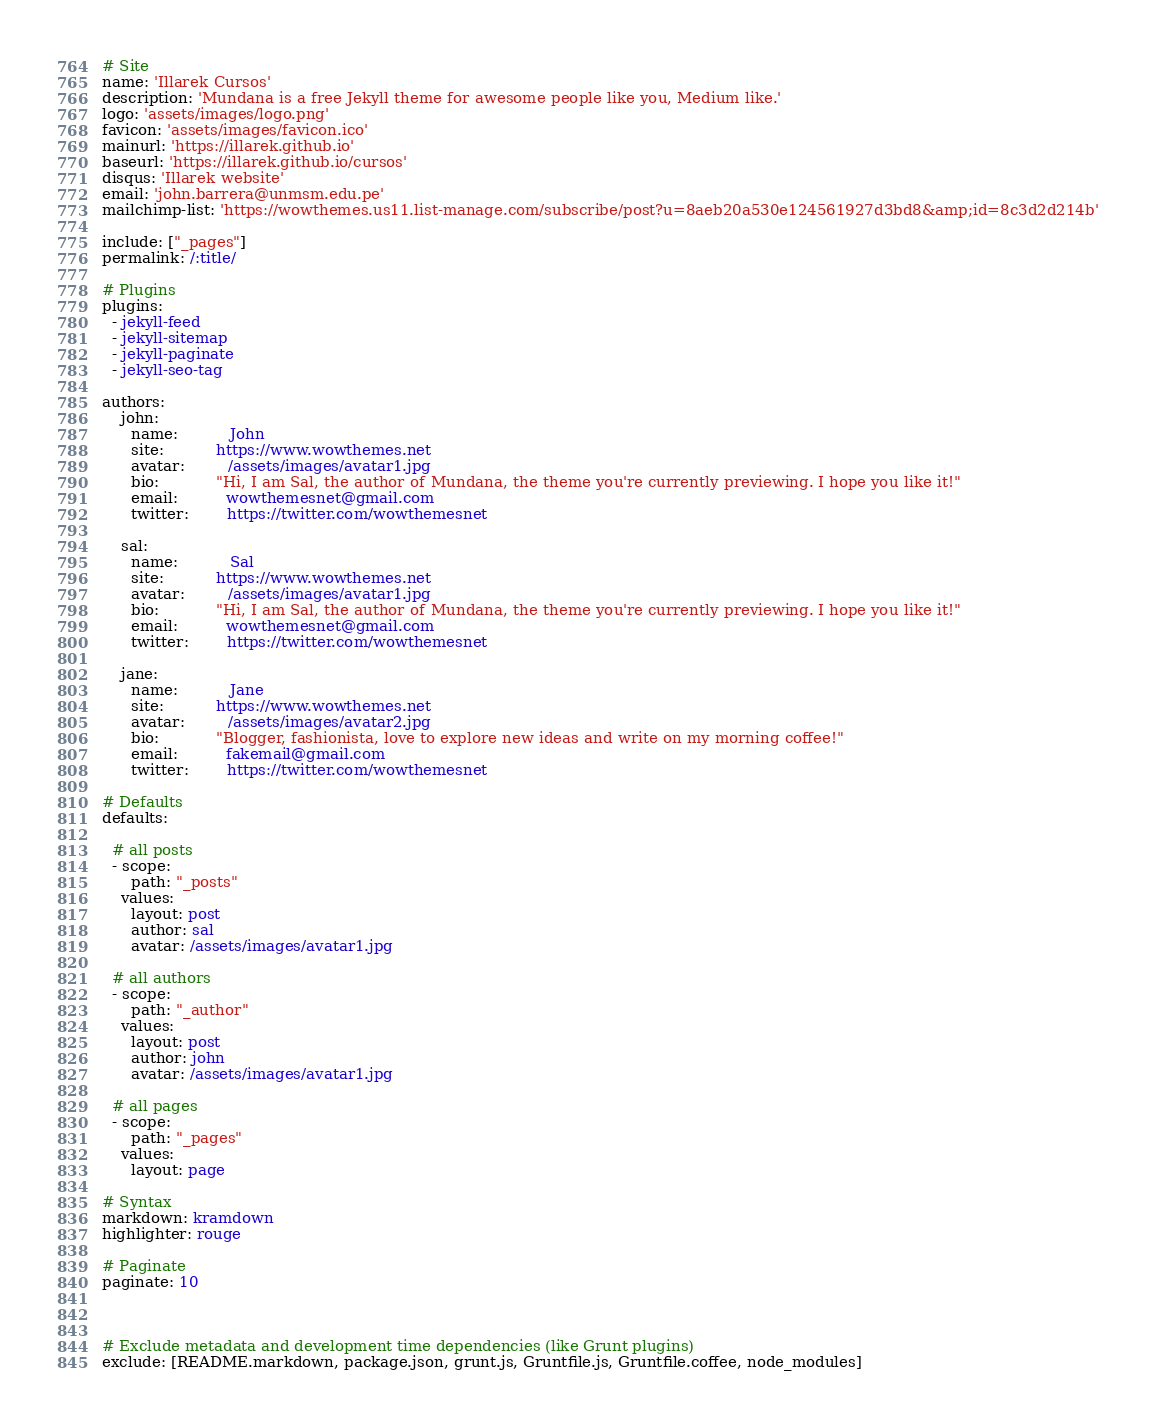Convert code to text. <code><loc_0><loc_0><loc_500><loc_500><_YAML_># Site
name: 'Illarek Cursos'
description: 'Mundana is a free Jekyll theme for awesome people like you, Medium like.'
logo: 'assets/images/logo.png'
favicon: 'assets/images/favicon.ico'
mainurl: 'https://illarek.github.io'
baseurl: 'https://illarek.github.io/cursos'
disqus: 'Illarek website'
email: 'john.barrera@unmsm.edu.pe'
mailchimp-list: 'https://wowthemes.us11.list-manage.com/subscribe/post?u=8aeb20a530e124561927d3bd8&amp;id=8c3d2d214b'

include: ["_pages"]
permalink: /:title/

# Plugins
plugins: 
  - jekyll-feed
  - jekyll-sitemap
  - jekyll-paginate
  - jekyll-seo-tag
  
authors:
    john:
      name:           John
      site:           https://www.wowthemes.net
      avatar:         /assets/images/avatar1.jpg
      bio:            "Hi, I am Sal, the author of Mundana, the theme you're currently previewing. I hope you like it!"
      email:          wowthemesnet@gmail.com
      twitter:        https://twitter.com/wowthemesnet

    sal:
      name:           Sal
      site:           https://www.wowthemes.net
      avatar:         /assets/images/avatar1.jpg
      bio:            "Hi, I am Sal, the author of Mundana, the theme you're currently previewing. I hope you like it!"
      email:          wowthemesnet@gmail.com
      twitter:        https://twitter.com/wowthemesnet

    jane:
      name:           Jane
      site:           https://www.wowthemes.net
      avatar:         /assets/images/avatar2.jpg
      bio:            "Blogger, fashionista, love to explore new ideas and write on my morning coffee!"
      email:          fakemail@gmail.com
      twitter:        https://twitter.com/wowthemesnet
 
# Defaults
defaults:

  # all posts
  - scope:
      path: "_posts"
    values:
      layout: post
      author: sal
      avatar: /assets/images/avatar1.jpg

  # all authors
  - scope:
      path: "_author"
    values:
      layout: post
      author: john
      avatar: /assets/images/avatar1.jpg
      
  # all pages
  - scope:
      path: "_pages"
    values:
      layout: page
      
# Syntax
markdown: kramdown
highlighter: rouge

# Paginate
paginate: 10



# Exclude metadata and development time dependencies (like Grunt plugins)
exclude: [README.markdown, package.json, grunt.js, Gruntfile.js, Gruntfile.coffee, node_modules]</code> 